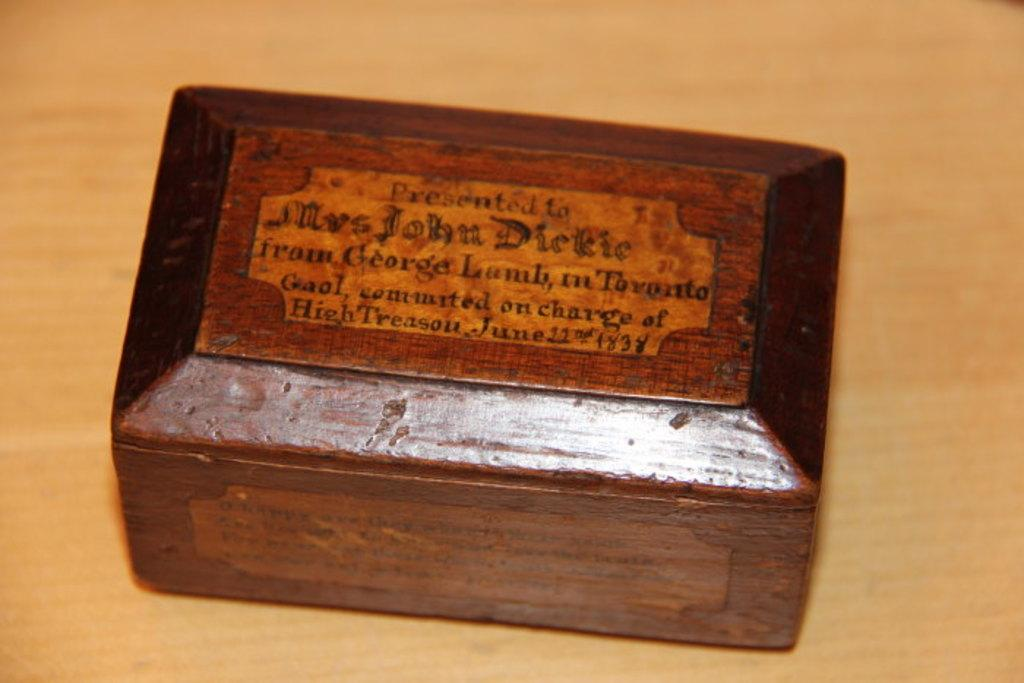<image>
Render a clear and concise summary of the photo. A document box opened with a label inside of the lid that says Presented To Mrs. John Dirkie. 